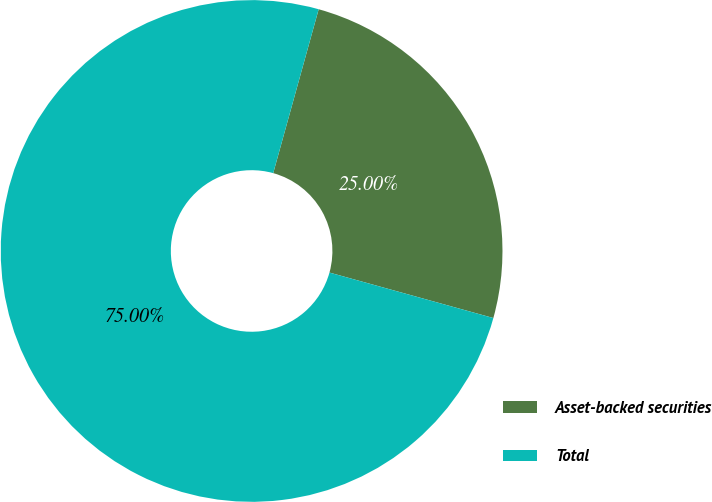<chart> <loc_0><loc_0><loc_500><loc_500><pie_chart><fcel>Asset-backed securities<fcel>Total<nl><fcel>25.0%<fcel>75.0%<nl></chart> 